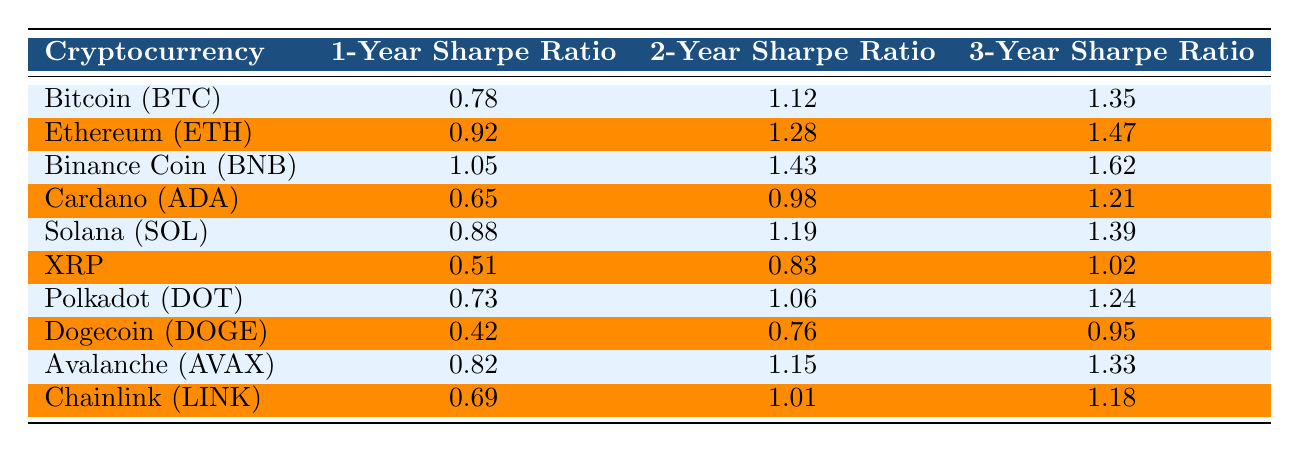What is the 3-Year Sharpe Ratio for Ethereum (ETH)? The table shows Ethereum (ETH) has a 3-Year Sharpe Ratio of 1.47 listed in the corresponding row.
Answer: 1.47 Which cryptocurrency has the highest 2-Year Sharpe Ratio? By examining the 2-Year Sharpe Ratios in the table, Binance Coin (BNB) has the highest value of 1.43.
Answer: Binance Coin (BNB) Is the 1-Year Sharpe Ratio for Dogecoin (DOGE) greater than 0.5? The table indicates that Dogecoin (DOGE) has a 1-Year Sharpe Ratio of 0.42, which is less than 0.5.
Answer: No What is the average 1-Year Sharpe Ratio for the listed cryptocurrencies? Adding the 1-Year Sharpe Ratios (0.78 + 0.92 + 1.05 + 0.65 + 0.88 + 0.51 + 0.73 + 0.42 + 0.82 + 0.69 = 7.65) and dividing by the total number (10) gives an average of 0.765.
Answer: 0.765 Which cryptocurrency has the lowest 3-Year Sharpe Ratio, and what is its value? Comparing the 3-Year Sharpe Ratios, Dogecoin (DOGE) has the lowest value at 0.95.
Answer: Dogecoin (DOGE), 0.95 What is the difference between the 3-Year Sharpe Ratios of Binance Coin (BNB) and XRP? The 3-Year Sharpe Ratio for Binance Coin (BNB) is 1.62, and for XRP, it is 1.02. The difference is 1.62 - 1.02 = 0.60.
Answer: 0.60 If we rank the cryptocurrencies by their 2-Year Sharpe Ratios, which one is in the third place? Listing the 2-Year Sharpe Ratios from highest to lowest: Binance Coin (BNB), Ethereum (ETH), and then Solana (SOL) in the third place.
Answer: Solana (SOL) Is the average 2-Year Sharpe Ratio for Bitcoin (BTC) and Cardano (ADA) greater or less than 1.0? The 2-Year Sharpe Ratio for Bitcoin (BTC) is 1.12 and for Cardano (ADA) is 0.98. Averaging these gives (1.12 + 0.98) / 2 = 1.05, which is greater than 1.0.
Answer: Greater What can be said about the overall trend of Sharpe Ratios over 1 Year, 2 Years, and 3 Years? Observing the table reveals that for all cryptocurrencies, the Sharpe Ratios tend to increase as the time frame extends from 1 year to 3 years.
Answer: They generally increase 